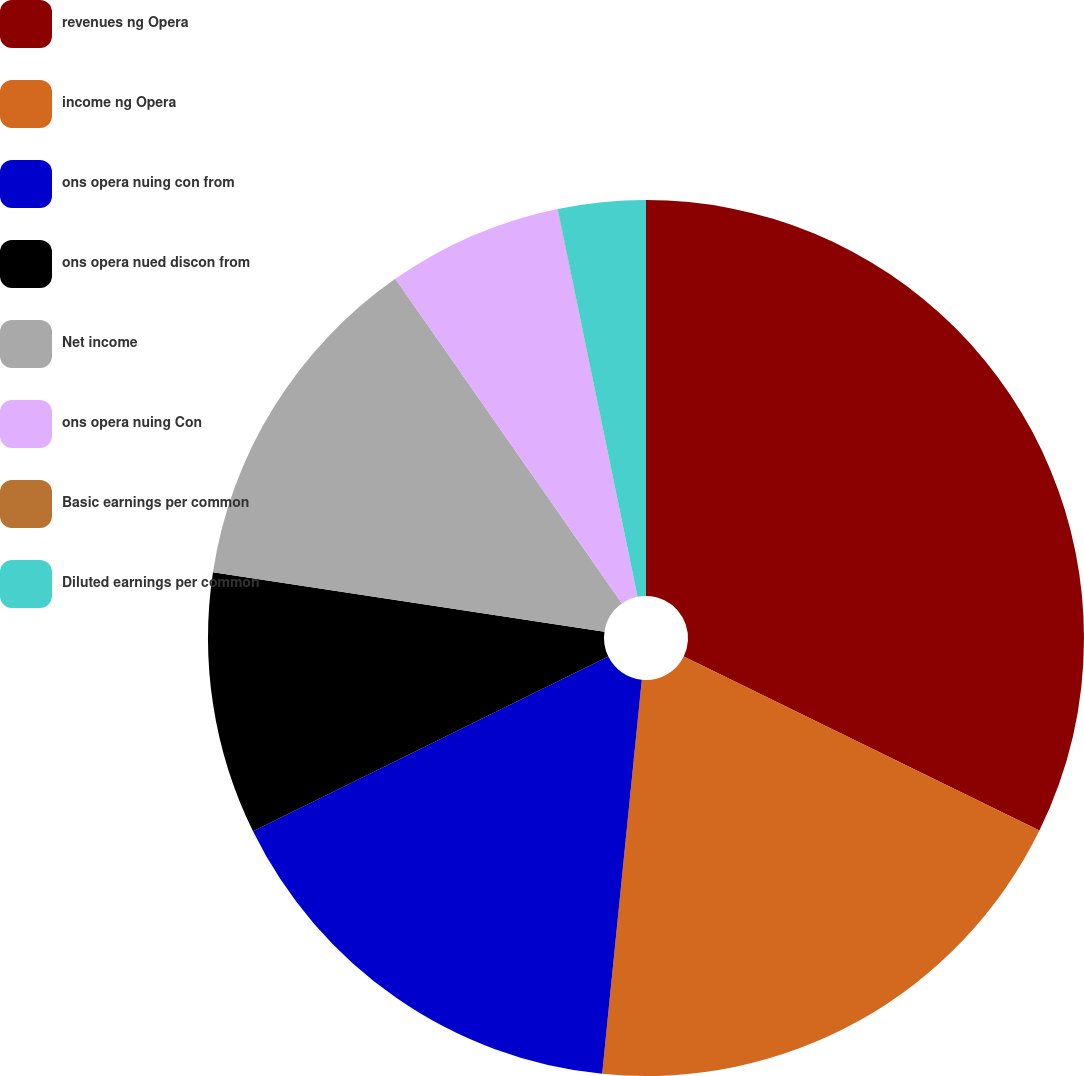<chart> <loc_0><loc_0><loc_500><loc_500><pie_chart><fcel>revenues ng Opera<fcel>income ng Opera<fcel>ons opera nuing con from<fcel>ons opera nued discon from<fcel>Net income<fcel>ons opera nuing Con<fcel>Basic earnings per common<fcel>Diluted earnings per common<nl><fcel>32.25%<fcel>19.35%<fcel>16.13%<fcel>9.68%<fcel>12.9%<fcel>6.46%<fcel>0.01%<fcel>3.23%<nl></chart> 